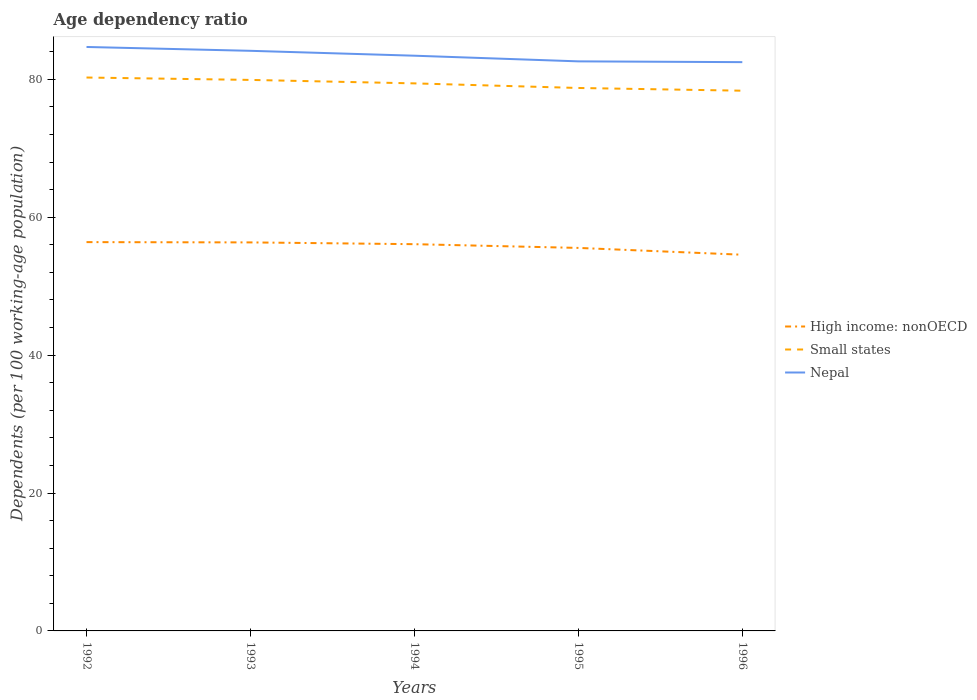How many different coloured lines are there?
Your response must be concise. 3. Does the line corresponding to Small states intersect with the line corresponding to Nepal?
Keep it short and to the point. No. Is the number of lines equal to the number of legend labels?
Provide a succinct answer. Yes. Across all years, what is the maximum age dependency ratio in in High income: nonOECD?
Your answer should be very brief. 54.57. In which year was the age dependency ratio in in High income: nonOECD maximum?
Keep it short and to the point. 1996. What is the total age dependency ratio in in Small states in the graph?
Keep it short and to the point. 1.06. What is the difference between the highest and the second highest age dependency ratio in in High income: nonOECD?
Keep it short and to the point. 1.83. What is the difference between the highest and the lowest age dependency ratio in in Nepal?
Keep it short and to the point. 2. Is the age dependency ratio in in High income: nonOECD strictly greater than the age dependency ratio in in Small states over the years?
Your answer should be compact. Yes. Are the values on the major ticks of Y-axis written in scientific E-notation?
Keep it short and to the point. No. Where does the legend appear in the graph?
Your response must be concise. Center right. What is the title of the graph?
Offer a terse response. Age dependency ratio. What is the label or title of the X-axis?
Give a very brief answer. Years. What is the label or title of the Y-axis?
Ensure brevity in your answer.  Dependents (per 100 working-age population). What is the Dependents (per 100 working-age population) of High income: nonOECD in 1992?
Your answer should be very brief. 56.4. What is the Dependents (per 100 working-age population) of Small states in 1992?
Give a very brief answer. 80.27. What is the Dependents (per 100 working-age population) of Nepal in 1992?
Provide a succinct answer. 84.7. What is the Dependents (per 100 working-age population) in High income: nonOECD in 1993?
Provide a short and direct response. 56.35. What is the Dependents (per 100 working-age population) of Small states in 1993?
Make the answer very short. 79.92. What is the Dependents (per 100 working-age population) of Nepal in 1993?
Keep it short and to the point. 84.14. What is the Dependents (per 100 working-age population) in High income: nonOECD in 1994?
Your answer should be very brief. 56.1. What is the Dependents (per 100 working-age population) in Small states in 1994?
Offer a very short reply. 79.42. What is the Dependents (per 100 working-age population) in Nepal in 1994?
Provide a short and direct response. 83.43. What is the Dependents (per 100 working-age population) in High income: nonOECD in 1995?
Keep it short and to the point. 55.55. What is the Dependents (per 100 working-age population) of Small states in 1995?
Your response must be concise. 78.75. What is the Dependents (per 100 working-age population) of Nepal in 1995?
Offer a very short reply. 82.61. What is the Dependents (per 100 working-age population) in High income: nonOECD in 1996?
Your response must be concise. 54.57. What is the Dependents (per 100 working-age population) of Small states in 1996?
Your answer should be compact. 78.36. What is the Dependents (per 100 working-age population) in Nepal in 1996?
Your answer should be very brief. 82.5. Across all years, what is the maximum Dependents (per 100 working-age population) in High income: nonOECD?
Offer a terse response. 56.4. Across all years, what is the maximum Dependents (per 100 working-age population) in Small states?
Your answer should be compact. 80.27. Across all years, what is the maximum Dependents (per 100 working-age population) in Nepal?
Ensure brevity in your answer.  84.7. Across all years, what is the minimum Dependents (per 100 working-age population) in High income: nonOECD?
Ensure brevity in your answer.  54.57. Across all years, what is the minimum Dependents (per 100 working-age population) of Small states?
Make the answer very short. 78.36. Across all years, what is the minimum Dependents (per 100 working-age population) in Nepal?
Your answer should be compact. 82.5. What is the total Dependents (per 100 working-age population) of High income: nonOECD in the graph?
Offer a very short reply. 278.96. What is the total Dependents (per 100 working-age population) of Small states in the graph?
Give a very brief answer. 396.72. What is the total Dependents (per 100 working-age population) in Nepal in the graph?
Offer a very short reply. 417.39. What is the difference between the Dependents (per 100 working-age population) of High income: nonOECD in 1992 and that in 1993?
Your answer should be very brief. 0.04. What is the difference between the Dependents (per 100 working-age population) in Small states in 1992 and that in 1993?
Give a very brief answer. 0.35. What is the difference between the Dependents (per 100 working-age population) of Nepal in 1992 and that in 1993?
Your answer should be compact. 0.56. What is the difference between the Dependents (per 100 working-age population) in High income: nonOECD in 1992 and that in 1994?
Offer a terse response. 0.3. What is the difference between the Dependents (per 100 working-age population) of Small states in 1992 and that in 1994?
Offer a very short reply. 0.85. What is the difference between the Dependents (per 100 working-age population) in Nepal in 1992 and that in 1994?
Give a very brief answer. 1.27. What is the difference between the Dependents (per 100 working-age population) in High income: nonOECD in 1992 and that in 1995?
Keep it short and to the point. 0.84. What is the difference between the Dependents (per 100 working-age population) of Small states in 1992 and that in 1995?
Your answer should be very brief. 1.52. What is the difference between the Dependents (per 100 working-age population) in Nepal in 1992 and that in 1995?
Your answer should be very brief. 2.09. What is the difference between the Dependents (per 100 working-age population) in High income: nonOECD in 1992 and that in 1996?
Provide a short and direct response. 1.83. What is the difference between the Dependents (per 100 working-age population) in Small states in 1992 and that in 1996?
Ensure brevity in your answer.  1.91. What is the difference between the Dependents (per 100 working-age population) in Nepal in 1992 and that in 1996?
Provide a succinct answer. 2.2. What is the difference between the Dependents (per 100 working-age population) of High income: nonOECD in 1993 and that in 1994?
Provide a succinct answer. 0.26. What is the difference between the Dependents (per 100 working-age population) in Small states in 1993 and that in 1994?
Ensure brevity in your answer.  0.5. What is the difference between the Dependents (per 100 working-age population) in Nepal in 1993 and that in 1994?
Offer a very short reply. 0.71. What is the difference between the Dependents (per 100 working-age population) in High income: nonOECD in 1993 and that in 1995?
Your response must be concise. 0.8. What is the difference between the Dependents (per 100 working-age population) in Small states in 1993 and that in 1995?
Your answer should be compact. 1.17. What is the difference between the Dependents (per 100 working-age population) of Nepal in 1993 and that in 1995?
Offer a very short reply. 1.53. What is the difference between the Dependents (per 100 working-age population) in High income: nonOECD in 1993 and that in 1996?
Your answer should be compact. 1.79. What is the difference between the Dependents (per 100 working-age population) of Small states in 1993 and that in 1996?
Ensure brevity in your answer.  1.56. What is the difference between the Dependents (per 100 working-age population) of Nepal in 1993 and that in 1996?
Offer a terse response. 1.64. What is the difference between the Dependents (per 100 working-age population) in High income: nonOECD in 1994 and that in 1995?
Ensure brevity in your answer.  0.54. What is the difference between the Dependents (per 100 working-age population) in Small states in 1994 and that in 1995?
Provide a short and direct response. 0.67. What is the difference between the Dependents (per 100 working-age population) of Nepal in 1994 and that in 1995?
Ensure brevity in your answer.  0.82. What is the difference between the Dependents (per 100 working-age population) in High income: nonOECD in 1994 and that in 1996?
Offer a terse response. 1.53. What is the difference between the Dependents (per 100 working-age population) of Small states in 1994 and that in 1996?
Your answer should be compact. 1.06. What is the difference between the Dependents (per 100 working-age population) of Nepal in 1994 and that in 1996?
Offer a terse response. 0.93. What is the difference between the Dependents (per 100 working-age population) of High income: nonOECD in 1995 and that in 1996?
Provide a succinct answer. 0.99. What is the difference between the Dependents (per 100 working-age population) of Small states in 1995 and that in 1996?
Provide a succinct answer. 0.4. What is the difference between the Dependents (per 100 working-age population) in Nepal in 1995 and that in 1996?
Your answer should be very brief. 0.11. What is the difference between the Dependents (per 100 working-age population) in High income: nonOECD in 1992 and the Dependents (per 100 working-age population) in Small states in 1993?
Keep it short and to the point. -23.53. What is the difference between the Dependents (per 100 working-age population) in High income: nonOECD in 1992 and the Dependents (per 100 working-age population) in Nepal in 1993?
Your answer should be compact. -27.75. What is the difference between the Dependents (per 100 working-age population) in Small states in 1992 and the Dependents (per 100 working-age population) in Nepal in 1993?
Provide a succinct answer. -3.87. What is the difference between the Dependents (per 100 working-age population) in High income: nonOECD in 1992 and the Dependents (per 100 working-age population) in Small states in 1994?
Your answer should be very brief. -23.02. What is the difference between the Dependents (per 100 working-age population) of High income: nonOECD in 1992 and the Dependents (per 100 working-age population) of Nepal in 1994?
Your answer should be compact. -27.04. What is the difference between the Dependents (per 100 working-age population) of Small states in 1992 and the Dependents (per 100 working-age population) of Nepal in 1994?
Ensure brevity in your answer.  -3.16. What is the difference between the Dependents (per 100 working-age population) in High income: nonOECD in 1992 and the Dependents (per 100 working-age population) in Small states in 1995?
Offer a terse response. -22.36. What is the difference between the Dependents (per 100 working-age population) of High income: nonOECD in 1992 and the Dependents (per 100 working-age population) of Nepal in 1995?
Make the answer very short. -26.22. What is the difference between the Dependents (per 100 working-age population) in Small states in 1992 and the Dependents (per 100 working-age population) in Nepal in 1995?
Provide a succinct answer. -2.34. What is the difference between the Dependents (per 100 working-age population) in High income: nonOECD in 1992 and the Dependents (per 100 working-age population) in Small states in 1996?
Offer a terse response. -21.96. What is the difference between the Dependents (per 100 working-age population) in High income: nonOECD in 1992 and the Dependents (per 100 working-age population) in Nepal in 1996?
Offer a terse response. -26.11. What is the difference between the Dependents (per 100 working-age population) of Small states in 1992 and the Dependents (per 100 working-age population) of Nepal in 1996?
Your response must be concise. -2.23. What is the difference between the Dependents (per 100 working-age population) in High income: nonOECD in 1993 and the Dependents (per 100 working-age population) in Small states in 1994?
Offer a terse response. -23.07. What is the difference between the Dependents (per 100 working-age population) of High income: nonOECD in 1993 and the Dependents (per 100 working-age population) of Nepal in 1994?
Keep it short and to the point. -27.08. What is the difference between the Dependents (per 100 working-age population) of Small states in 1993 and the Dependents (per 100 working-age population) of Nepal in 1994?
Ensure brevity in your answer.  -3.51. What is the difference between the Dependents (per 100 working-age population) in High income: nonOECD in 1993 and the Dependents (per 100 working-age population) in Small states in 1995?
Offer a very short reply. -22.4. What is the difference between the Dependents (per 100 working-age population) in High income: nonOECD in 1993 and the Dependents (per 100 working-age population) in Nepal in 1995?
Provide a succinct answer. -26.26. What is the difference between the Dependents (per 100 working-age population) in Small states in 1993 and the Dependents (per 100 working-age population) in Nepal in 1995?
Keep it short and to the point. -2.69. What is the difference between the Dependents (per 100 working-age population) of High income: nonOECD in 1993 and the Dependents (per 100 working-age population) of Small states in 1996?
Make the answer very short. -22. What is the difference between the Dependents (per 100 working-age population) of High income: nonOECD in 1993 and the Dependents (per 100 working-age population) of Nepal in 1996?
Keep it short and to the point. -26.15. What is the difference between the Dependents (per 100 working-age population) of Small states in 1993 and the Dependents (per 100 working-age population) of Nepal in 1996?
Offer a terse response. -2.58. What is the difference between the Dependents (per 100 working-age population) in High income: nonOECD in 1994 and the Dependents (per 100 working-age population) in Small states in 1995?
Make the answer very short. -22.66. What is the difference between the Dependents (per 100 working-age population) in High income: nonOECD in 1994 and the Dependents (per 100 working-age population) in Nepal in 1995?
Your response must be concise. -26.52. What is the difference between the Dependents (per 100 working-age population) in Small states in 1994 and the Dependents (per 100 working-age population) in Nepal in 1995?
Provide a short and direct response. -3.19. What is the difference between the Dependents (per 100 working-age population) in High income: nonOECD in 1994 and the Dependents (per 100 working-age population) in Small states in 1996?
Offer a very short reply. -22.26. What is the difference between the Dependents (per 100 working-age population) of High income: nonOECD in 1994 and the Dependents (per 100 working-age population) of Nepal in 1996?
Offer a terse response. -26.41. What is the difference between the Dependents (per 100 working-age population) of Small states in 1994 and the Dependents (per 100 working-age population) of Nepal in 1996?
Your answer should be very brief. -3.08. What is the difference between the Dependents (per 100 working-age population) in High income: nonOECD in 1995 and the Dependents (per 100 working-age population) in Small states in 1996?
Ensure brevity in your answer.  -22.8. What is the difference between the Dependents (per 100 working-age population) in High income: nonOECD in 1995 and the Dependents (per 100 working-age population) in Nepal in 1996?
Ensure brevity in your answer.  -26.95. What is the difference between the Dependents (per 100 working-age population) in Small states in 1995 and the Dependents (per 100 working-age population) in Nepal in 1996?
Offer a very short reply. -3.75. What is the average Dependents (per 100 working-age population) in High income: nonOECD per year?
Provide a short and direct response. 55.79. What is the average Dependents (per 100 working-age population) in Small states per year?
Offer a very short reply. 79.34. What is the average Dependents (per 100 working-age population) of Nepal per year?
Your response must be concise. 83.48. In the year 1992, what is the difference between the Dependents (per 100 working-age population) of High income: nonOECD and Dependents (per 100 working-age population) of Small states?
Give a very brief answer. -23.87. In the year 1992, what is the difference between the Dependents (per 100 working-age population) of High income: nonOECD and Dependents (per 100 working-age population) of Nepal?
Provide a succinct answer. -28.31. In the year 1992, what is the difference between the Dependents (per 100 working-age population) in Small states and Dependents (per 100 working-age population) in Nepal?
Provide a succinct answer. -4.43. In the year 1993, what is the difference between the Dependents (per 100 working-age population) of High income: nonOECD and Dependents (per 100 working-age population) of Small states?
Give a very brief answer. -23.57. In the year 1993, what is the difference between the Dependents (per 100 working-age population) of High income: nonOECD and Dependents (per 100 working-age population) of Nepal?
Offer a very short reply. -27.79. In the year 1993, what is the difference between the Dependents (per 100 working-age population) of Small states and Dependents (per 100 working-age population) of Nepal?
Offer a very short reply. -4.22. In the year 1994, what is the difference between the Dependents (per 100 working-age population) in High income: nonOECD and Dependents (per 100 working-age population) in Small states?
Offer a terse response. -23.32. In the year 1994, what is the difference between the Dependents (per 100 working-age population) in High income: nonOECD and Dependents (per 100 working-age population) in Nepal?
Keep it short and to the point. -27.34. In the year 1994, what is the difference between the Dependents (per 100 working-age population) in Small states and Dependents (per 100 working-age population) in Nepal?
Your answer should be very brief. -4.01. In the year 1995, what is the difference between the Dependents (per 100 working-age population) of High income: nonOECD and Dependents (per 100 working-age population) of Small states?
Your response must be concise. -23.2. In the year 1995, what is the difference between the Dependents (per 100 working-age population) in High income: nonOECD and Dependents (per 100 working-age population) in Nepal?
Your answer should be compact. -27.06. In the year 1995, what is the difference between the Dependents (per 100 working-age population) in Small states and Dependents (per 100 working-age population) in Nepal?
Offer a very short reply. -3.86. In the year 1996, what is the difference between the Dependents (per 100 working-age population) in High income: nonOECD and Dependents (per 100 working-age population) in Small states?
Keep it short and to the point. -23.79. In the year 1996, what is the difference between the Dependents (per 100 working-age population) of High income: nonOECD and Dependents (per 100 working-age population) of Nepal?
Your response must be concise. -27.93. In the year 1996, what is the difference between the Dependents (per 100 working-age population) of Small states and Dependents (per 100 working-age population) of Nepal?
Offer a terse response. -4.14. What is the ratio of the Dependents (per 100 working-age population) of High income: nonOECD in 1992 to that in 1993?
Give a very brief answer. 1. What is the ratio of the Dependents (per 100 working-age population) of Nepal in 1992 to that in 1993?
Ensure brevity in your answer.  1.01. What is the ratio of the Dependents (per 100 working-age population) in High income: nonOECD in 1992 to that in 1994?
Your answer should be compact. 1.01. What is the ratio of the Dependents (per 100 working-age population) of Small states in 1992 to that in 1994?
Your response must be concise. 1.01. What is the ratio of the Dependents (per 100 working-age population) in Nepal in 1992 to that in 1994?
Your answer should be very brief. 1.02. What is the ratio of the Dependents (per 100 working-age population) in High income: nonOECD in 1992 to that in 1995?
Provide a short and direct response. 1.02. What is the ratio of the Dependents (per 100 working-age population) in Small states in 1992 to that in 1995?
Offer a very short reply. 1.02. What is the ratio of the Dependents (per 100 working-age population) in Nepal in 1992 to that in 1995?
Keep it short and to the point. 1.03. What is the ratio of the Dependents (per 100 working-age population) in High income: nonOECD in 1992 to that in 1996?
Your answer should be very brief. 1.03. What is the ratio of the Dependents (per 100 working-age population) of Small states in 1992 to that in 1996?
Provide a succinct answer. 1.02. What is the ratio of the Dependents (per 100 working-age population) of Nepal in 1992 to that in 1996?
Your answer should be very brief. 1.03. What is the ratio of the Dependents (per 100 working-age population) in High income: nonOECD in 1993 to that in 1994?
Provide a succinct answer. 1. What is the ratio of the Dependents (per 100 working-age population) in Nepal in 1993 to that in 1994?
Provide a short and direct response. 1.01. What is the ratio of the Dependents (per 100 working-age population) in High income: nonOECD in 1993 to that in 1995?
Keep it short and to the point. 1.01. What is the ratio of the Dependents (per 100 working-age population) in Small states in 1993 to that in 1995?
Offer a terse response. 1.01. What is the ratio of the Dependents (per 100 working-age population) of Nepal in 1993 to that in 1995?
Your answer should be compact. 1.02. What is the ratio of the Dependents (per 100 working-age population) in High income: nonOECD in 1993 to that in 1996?
Provide a short and direct response. 1.03. What is the ratio of the Dependents (per 100 working-age population) of Small states in 1993 to that in 1996?
Your answer should be compact. 1.02. What is the ratio of the Dependents (per 100 working-age population) of Nepal in 1993 to that in 1996?
Your answer should be very brief. 1.02. What is the ratio of the Dependents (per 100 working-age population) of High income: nonOECD in 1994 to that in 1995?
Ensure brevity in your answer.  1.01. What is the ratio of the Dependents (per 100 working-age population) of Small states in 1994 to that in 1995?
Provide a succinct answer. 1.01. What is the ratio of the Dependents (per 100 working-age population) in Nepal in 1994 to that in 1995?
Offer a terse response. 1.01. What is the ratio of the Dependents (per 100 working-age population) of High income: nonOECD in 1994 to that in 1996?
Your response must be concise. 1.03. What is the ratio of the Dependents (per 100 working-age population) of Small states in 1994 to that in 1996?
Your response must be concise. 1.01. What is the ratio of the Dependents (per 100 working-age population) of Nepal in 1994 to that in 1996?
Give a very brief answer. 1.01. What is the ratio of the Dependents (per 100 working-age population) in High income: nonOECD in 1995 to that in 1996?
Provide a succinct answer. 1.02. What is the ratio of the Dependents (per 100 working-age population) of Small states in 1995 to that in 1996?
Offer a terse response. 1. What is the difference between the highest and the second highest Dependents (per 100 working-age population) in High income: nonOECD?
Your answer should be compact. 0.04. What is the difference between the highest and the second highest Dependents (per 100 working-age population) of Small states?
Offer a very short reply. 0.35. What is the difference between the highest and the second highest Dependents (per 100 working-age population) of Nepal?
Offer a very short reply. 0.56. What is the difference between the highest and the lowest Dependents (per 100 working-age population) of High income: nonOECD?
Your answer should be compact. 1.83. What is the difference between the highest and the lowest Dependents (per 100 working-age population) in Small states?
Ensure brevity in your answer.  1.91. What is the difference between the highest and the lowest Dependents (per 100 working-age population) in Nepal?
Your answer should be very brief. 2.2. 